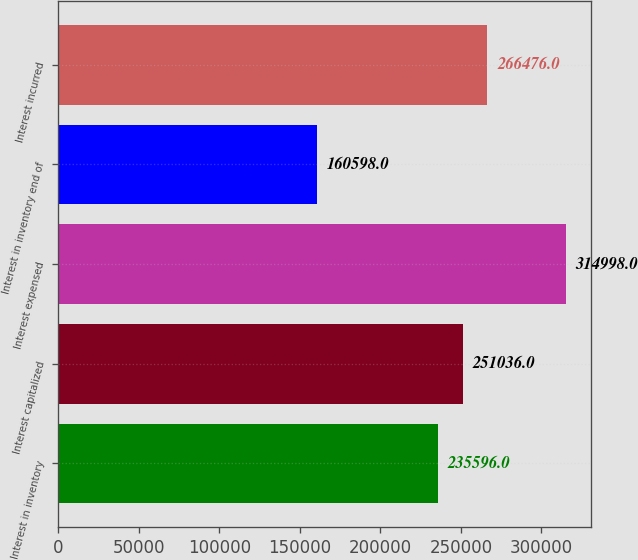Convert chart. <chart><loc_0><loc_0><loc_500><loc_500><bar_chart><fcel>Interest in inventory<fcel>Interest capitalized<fcel>Interest expensed<fcel>Interest in inventory end of<fcel>Interest incurred<nl><fcel>235596<fcel>251036<fcel>314998<fcel>160598<fcel>266476<nl></chart> 